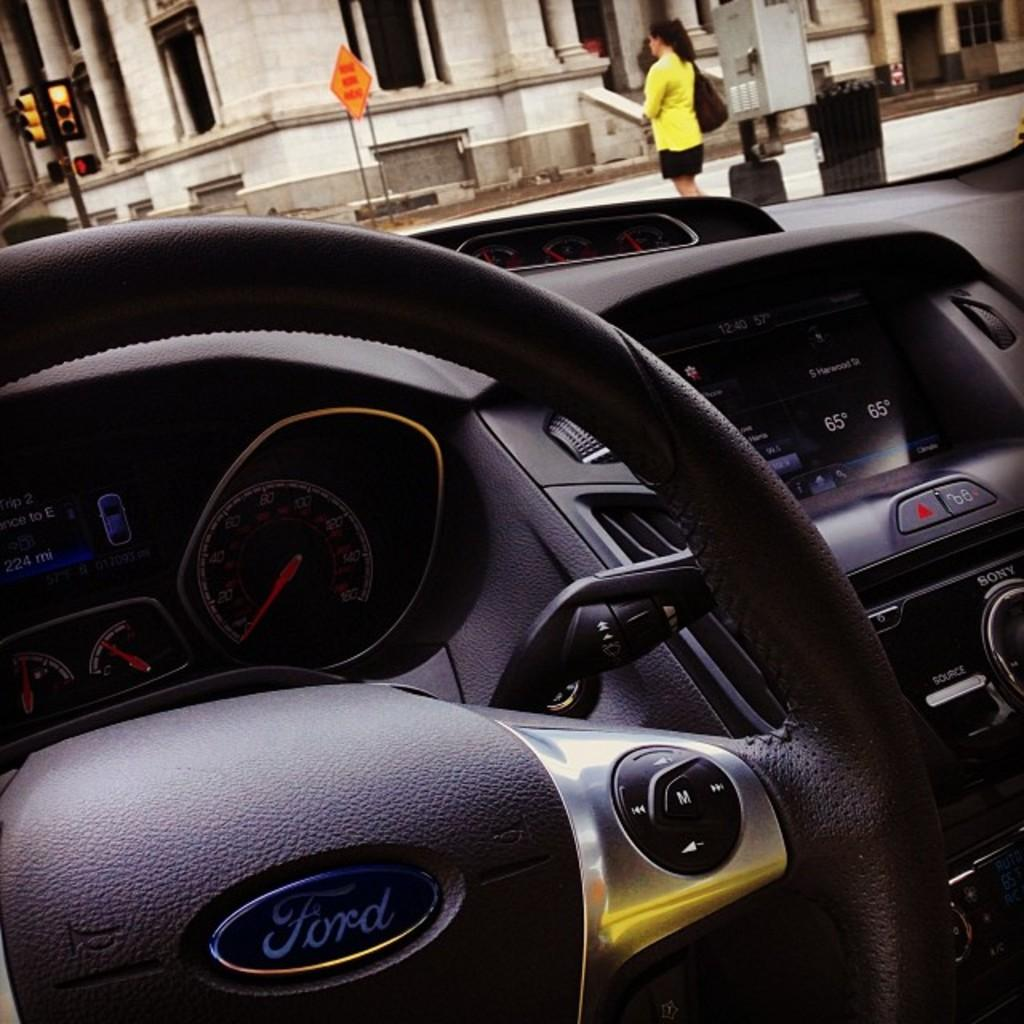What is the perspective of the image? The image is taken from inside a car. What can be seen inside the car? The steering wheel and dashboard of the car are visible in the image. What is visible outside the car through the glass? A lady standing on a footpath, poles, and a building are visible through the glass. What type of meat can be seen hanging from the poles in the image? There is no meat visible in the image; only a lady, poles, and a building can be seen through the glass. 